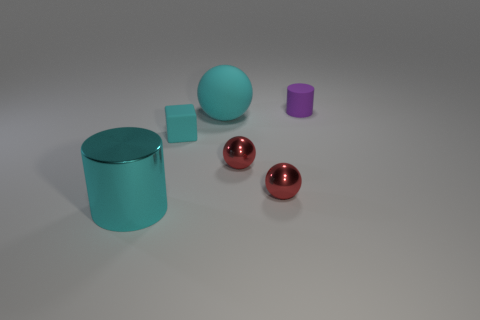Does the large object to the right of the large metal object have the same material as the large cyan cylinder?
Your answer should be very brief. No. Are there any spheres made of the same material as the tiny cyan block?
Your answer should be compact. Yes. Do the big thing that is right of the cyan shiny thing and the small cyan thing have the same shape?
Give a very brief answer. No. What number of tiny cylinders are on the left side of the small matte object left of the cylinder that is behind the big shiny thing?
Ensure brevity in your answer.  0. Are there fewer large spheres in front of the large cyan metallic cylinder than blocks on the right side of the big cyan rubber thing?
Offer a terse response. No. What color is the other big thing that is the same shape as the purple object?
Your answer should be very brief. Cyan. What is the size of the metal cylinder?
Give a very brief answer. Large. How many purple objects are the same size as the matte ball?
Make the answer very short. 0. Do the small cube and the large metal cylinder have the same color?
Your answer should be very brief. Yes. Is the cylinder that is right of the cyan metal thing made of the same material as the cyan object behind the cyan cube?
Keep it short and to the point. Yes. 